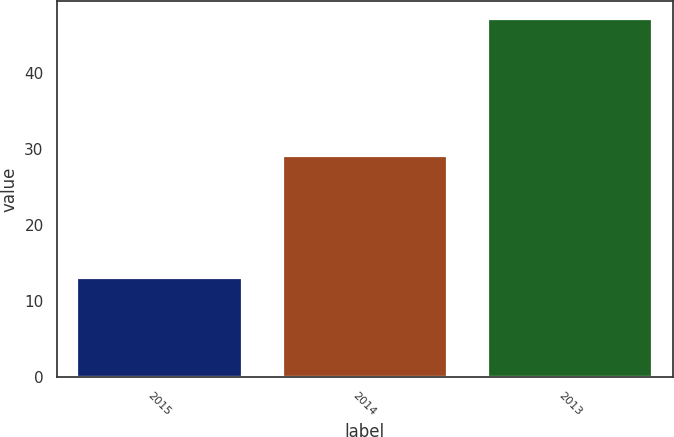Convert chart to OTSL. <chart><loc_0><loc_0><loc_500><loc_500><bar_chart><fcel>2015<fcel>2014<fcel>2013<nl><fcel>13<fcel>29<fcel>47<nl></chart> 